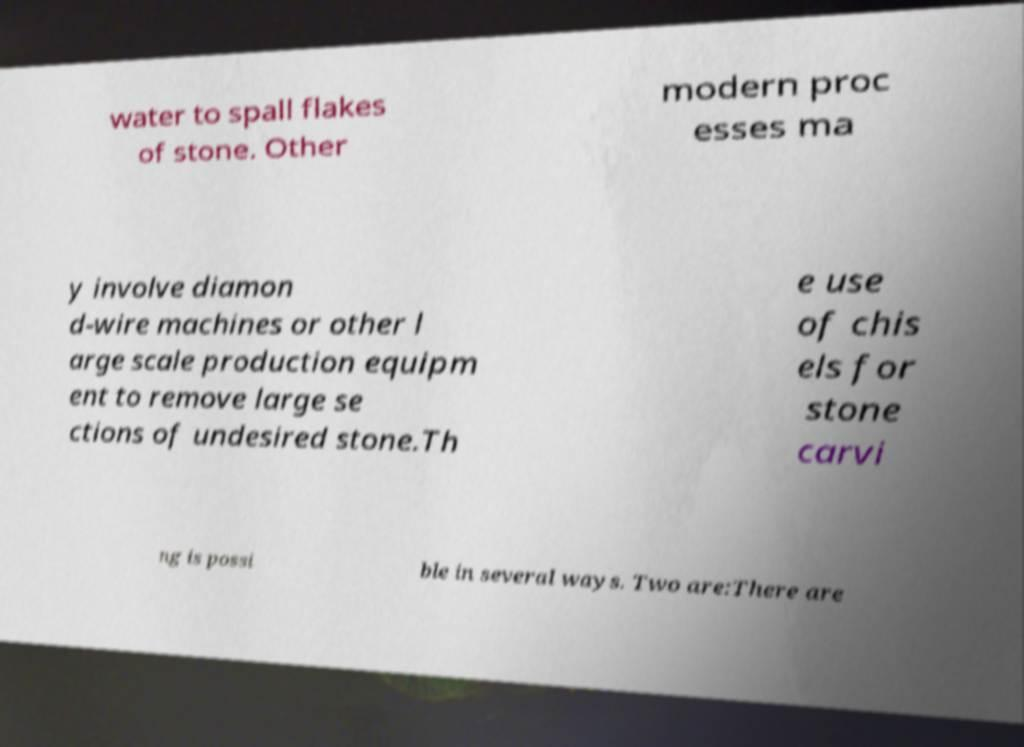What messages or text are displayed in this image? I need them in a readable, typed format. water to spall flakes of stone. Other modern proc esses ma y involve diamon d-wire machines or other l arge scale production equipm ent to remove large se ctions of undesired stone.Th e use of chis els for stone carvi ng is possi ble in several ways. Two are:There are 